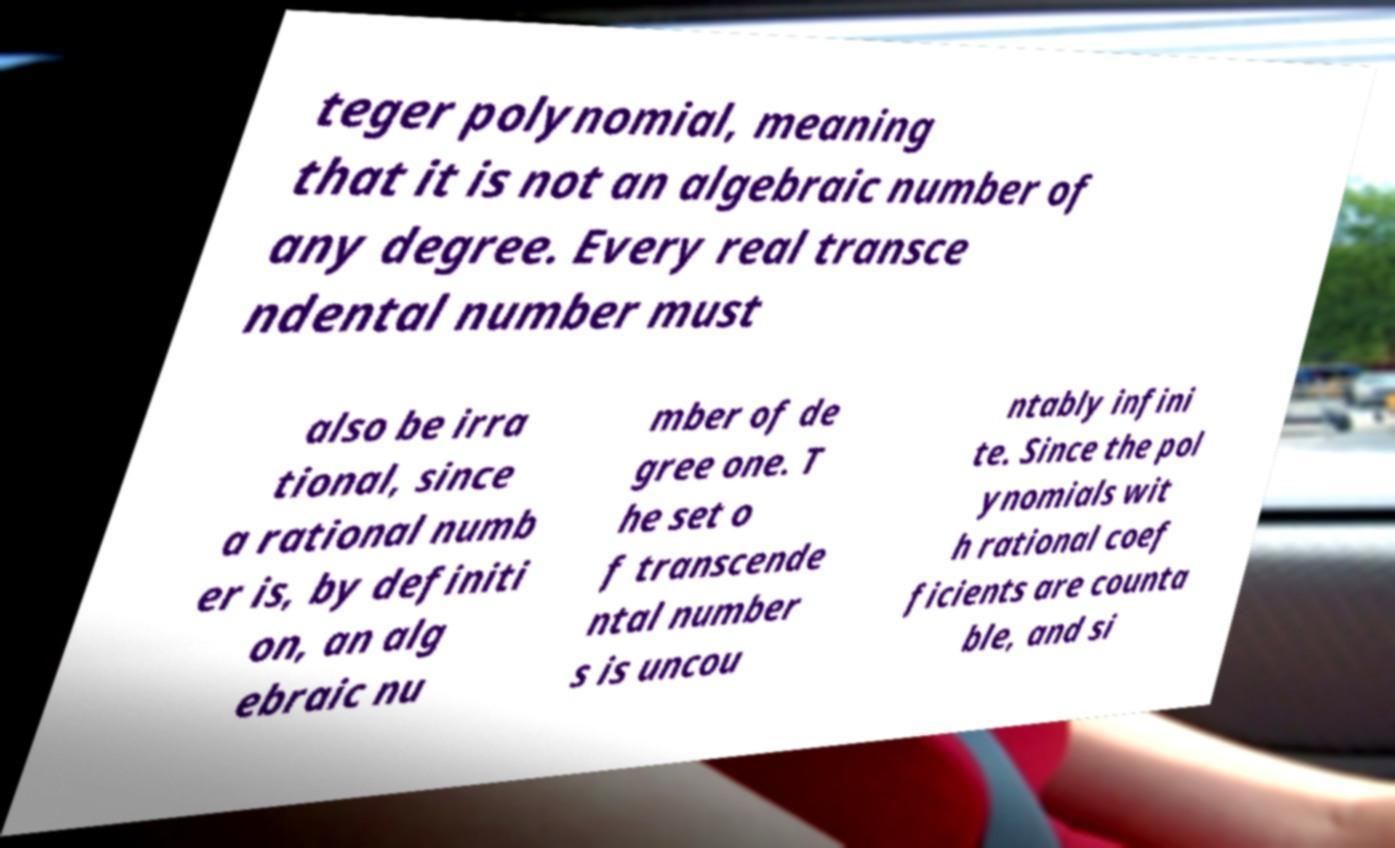Can you read and provide the text displayed in the image?This photo seems to have some interesting text. Can you extract and type it out for me? teger polynomial, meaning that it is not an algebraic number of any degree. Every real transce ndental number must also be irra tional, since a rational numb er is, by definiti on, an alg ebraic nu mber of de gree one. T he set o f transcende ntal number s is uncou ntably infini te. Since the pol ynomials wit h rational coef ficients are counta ble, and si 